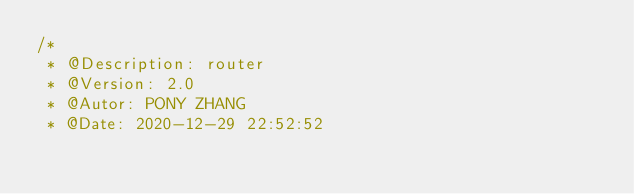<code> <loc_0><loc_0><loc_500><loc_500><_JavaScript_>/*
 * @Description: router
 * @Version: 2.0
 * @Autor: PONY ZHANG
 * @Date: 2020-12-29 22:52:52</code> 